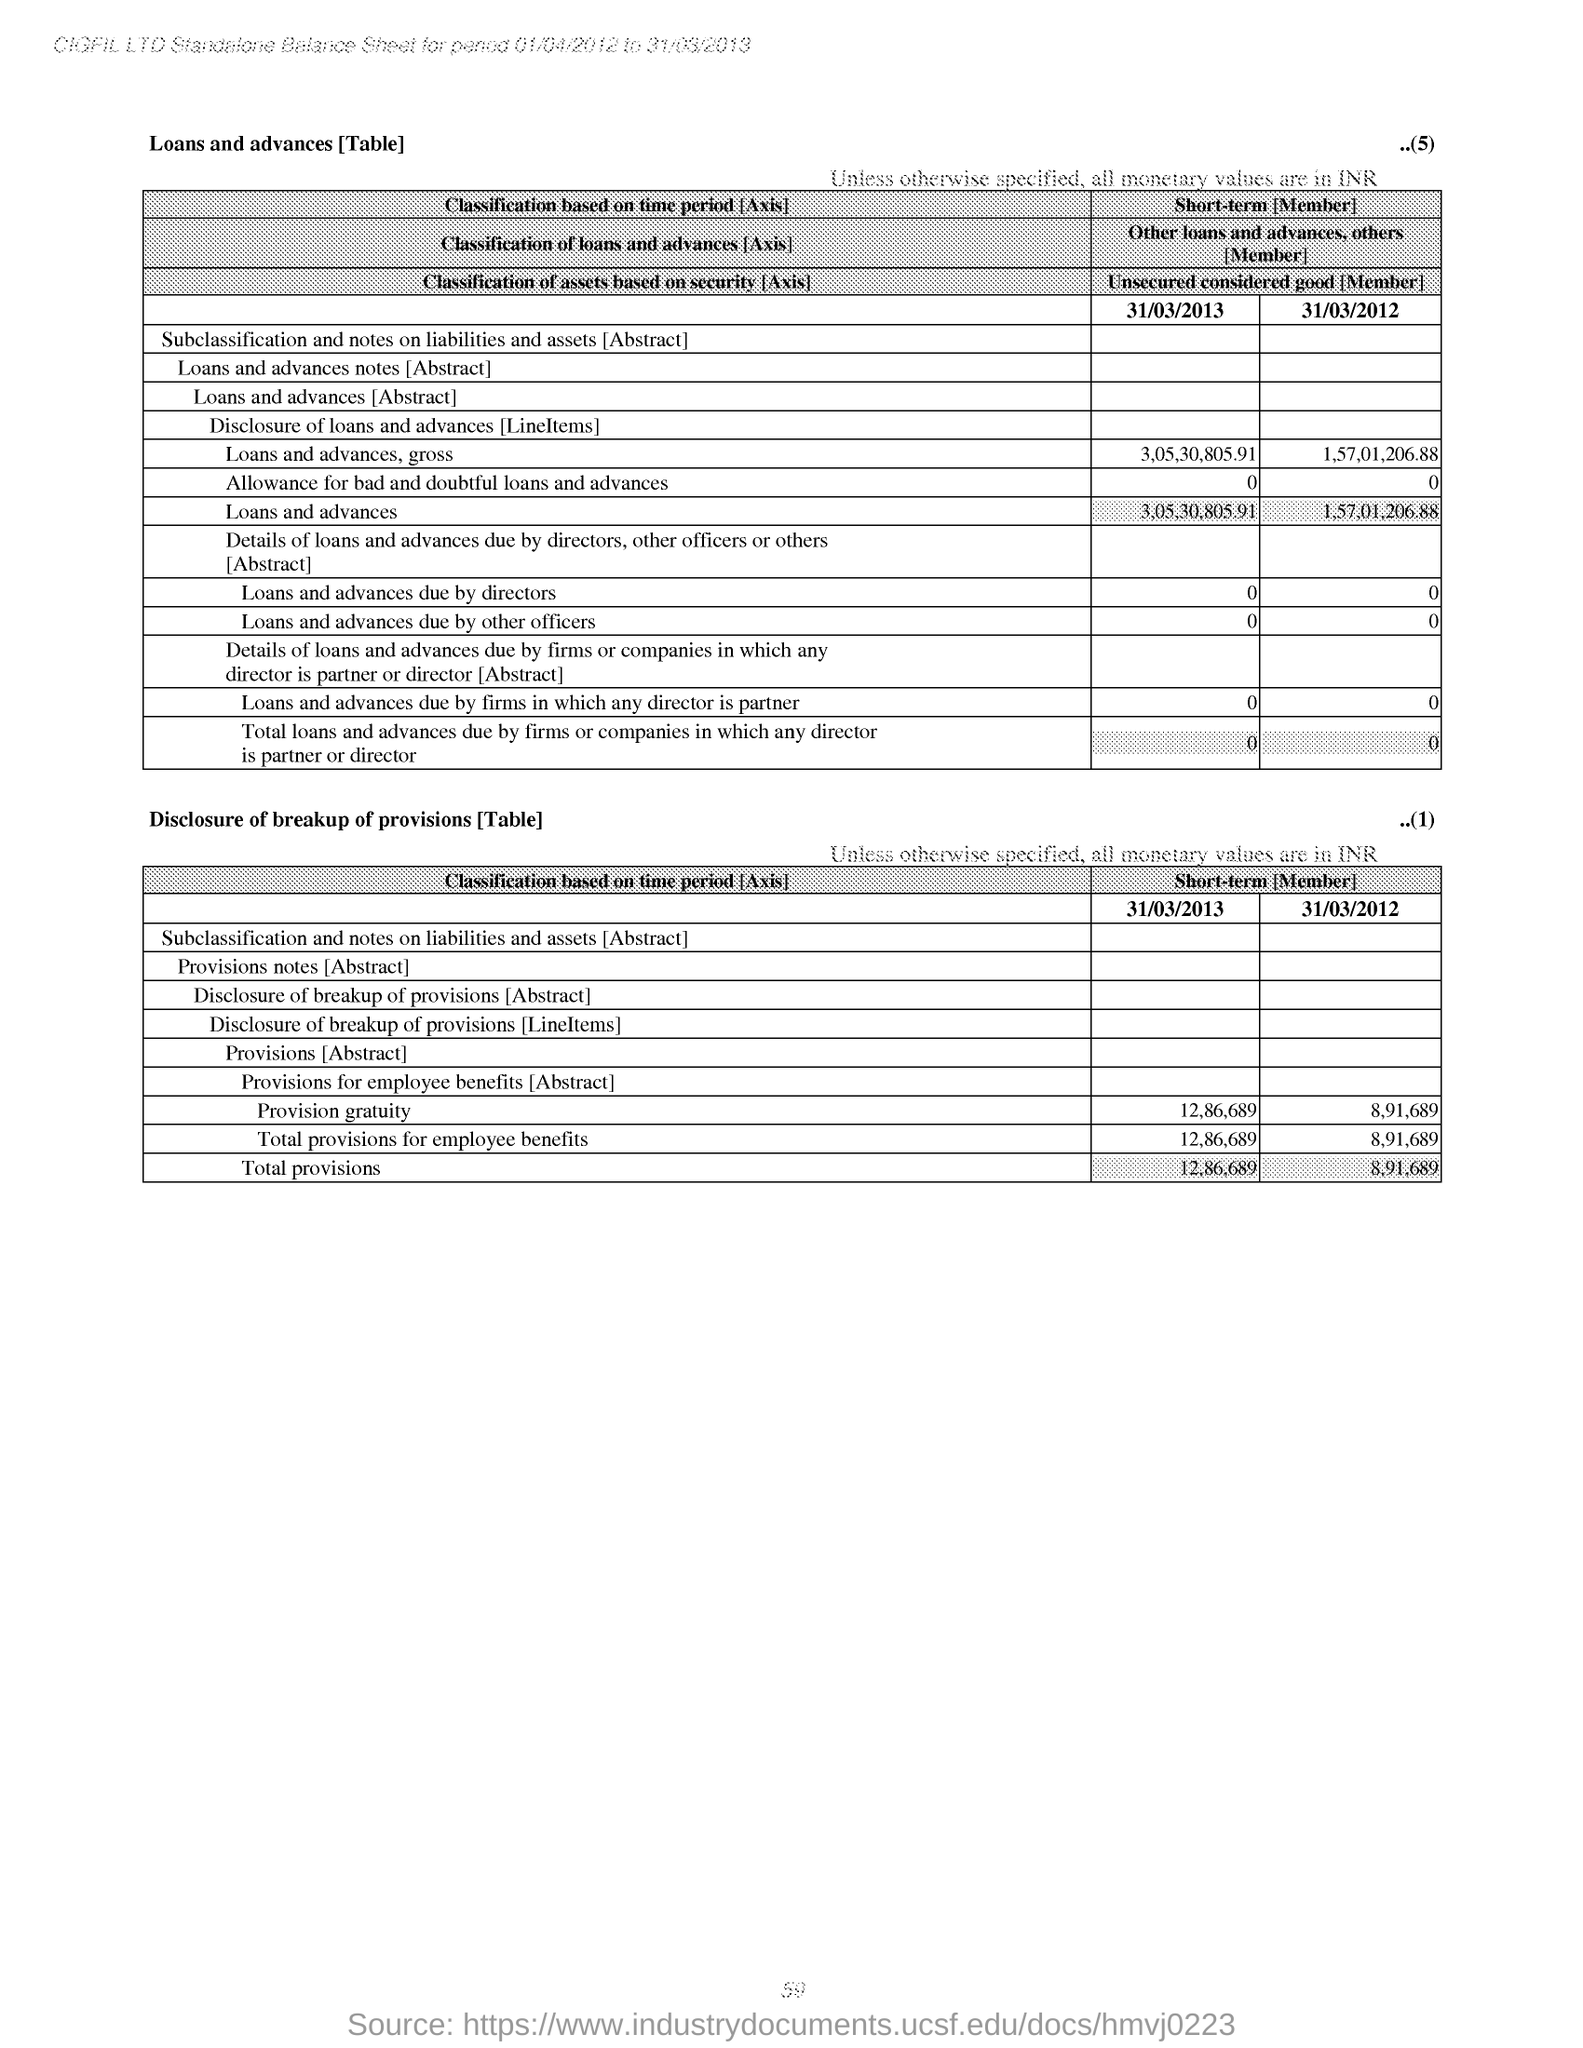What is the Total Provisions for 31/03/2013?
Provide a succinct answer. 12,86,689. What is the Total Provisions for 31/03/2012?
Keep it short and to the point. 8,91,689. What is the Total Provisions for employee benefits for 31/03/2013?
Your response must be concise. 12,86,689. What is the Total Provisions for employee benefits for 31/03/2012?
Offer a very short reply. 8,91,689. What is the loans and advances due by directors for 31/03/2013?
Provide a succinct answer. 0. What is the loans and advances due by directors for 31/03/2012?
Your response must be concise. 0. What is the loans and advances gross for 31/03/2013?
Provide a short and direct response. 3,05,30,805.91. What is the loans and advances gross for 31/03/2012?
Your response must be concise. 1,57,01,206.88. What is the loans and advances for 31/03/2013?
Keep it short and to the point. 3,05,30,805.91. What is the loans and advances for 31/03/2012?
Provide a short and direct response. 1,57,01,206.88. 